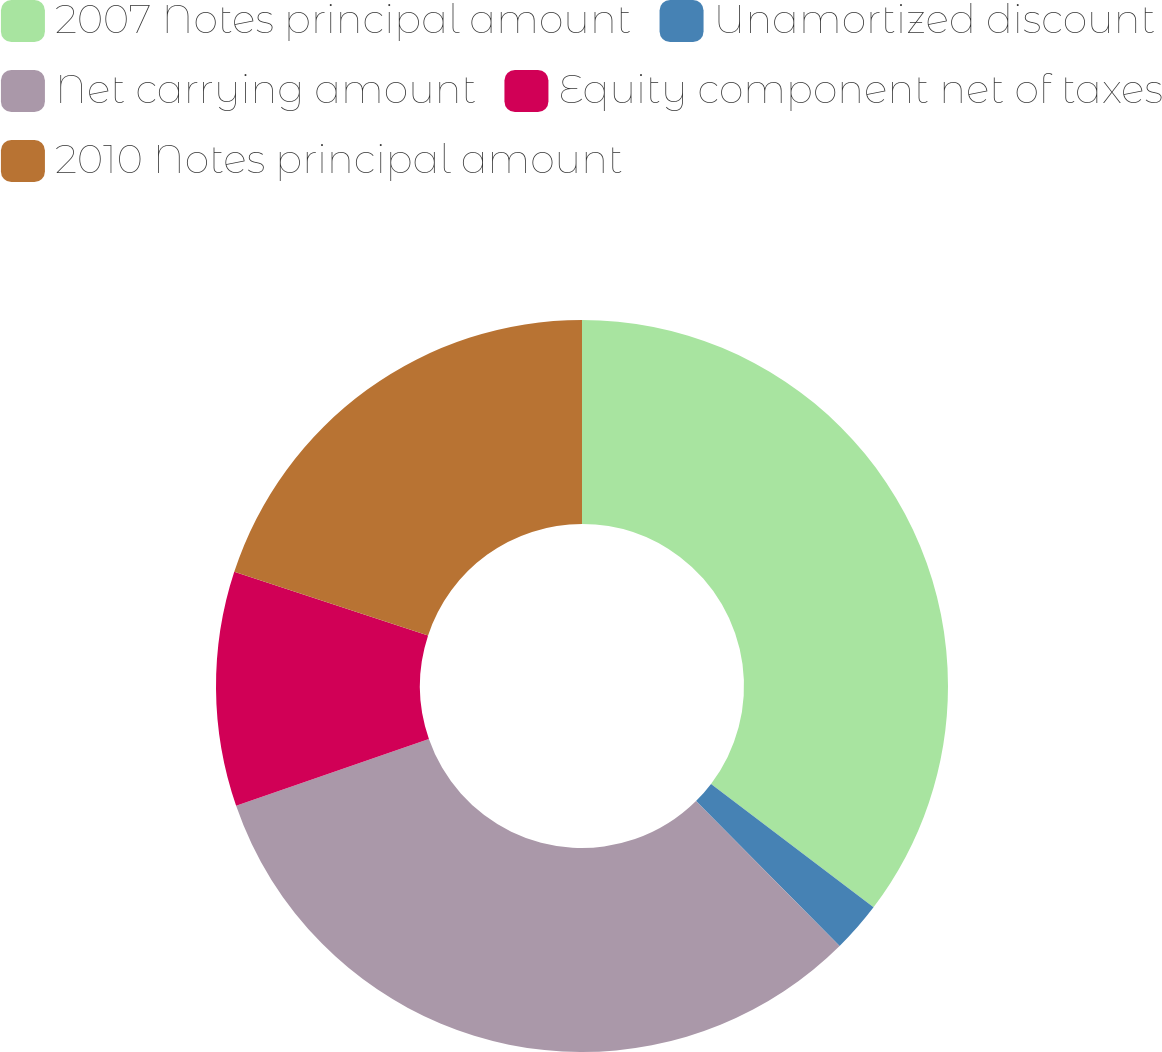<chart> <loc_0><loc_0><loc_500><loc_500><pie_chart><fcel>2007 Notes principal amount<fcel>Unamortized discount<fcel>Net carrying amount<fcel>Equity component net of taxes<fcel>2010 Notes principal amount<nl><fcel>35.33%<fcel>2.24%<fcel>32.12%<fcel>10.35%<fcel>19.95%<nl></chart> 